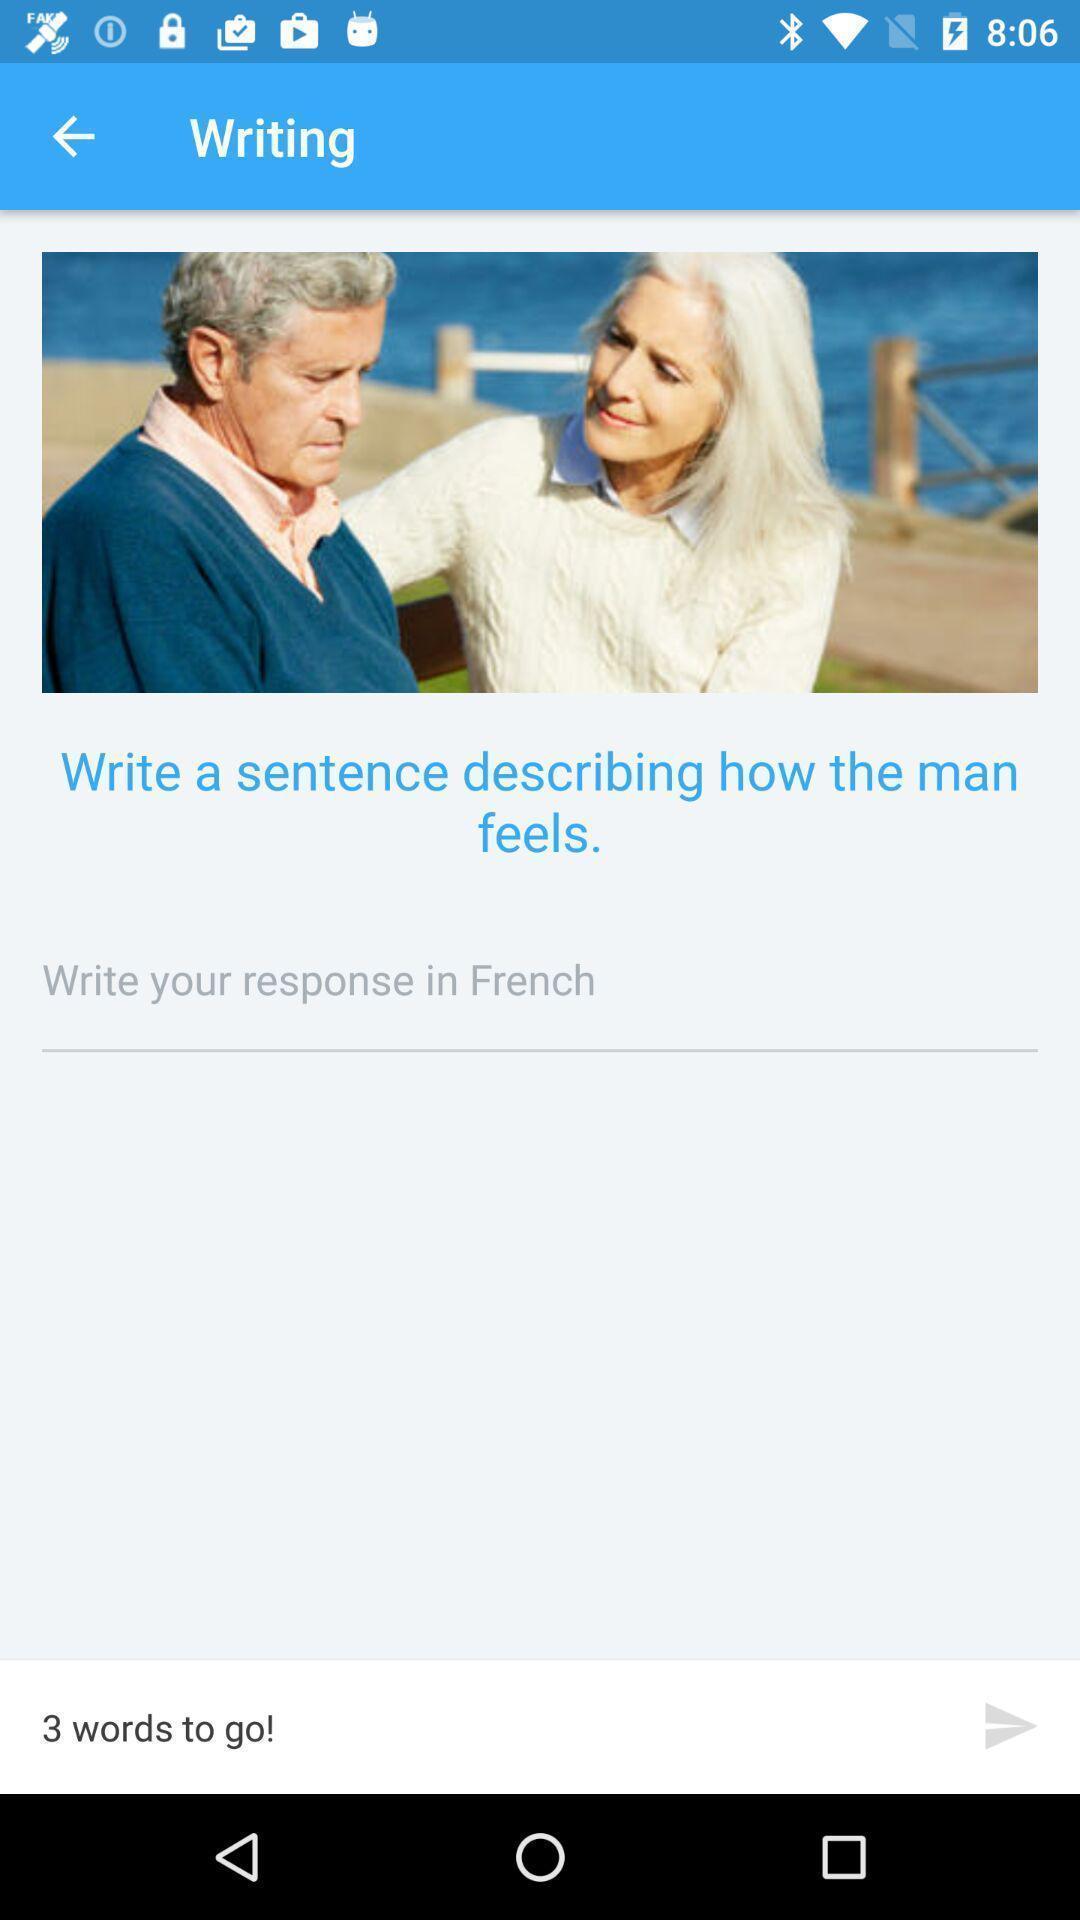Provide a detailed account of this screenshot. Writing page displayed includes an image in language learning app. 